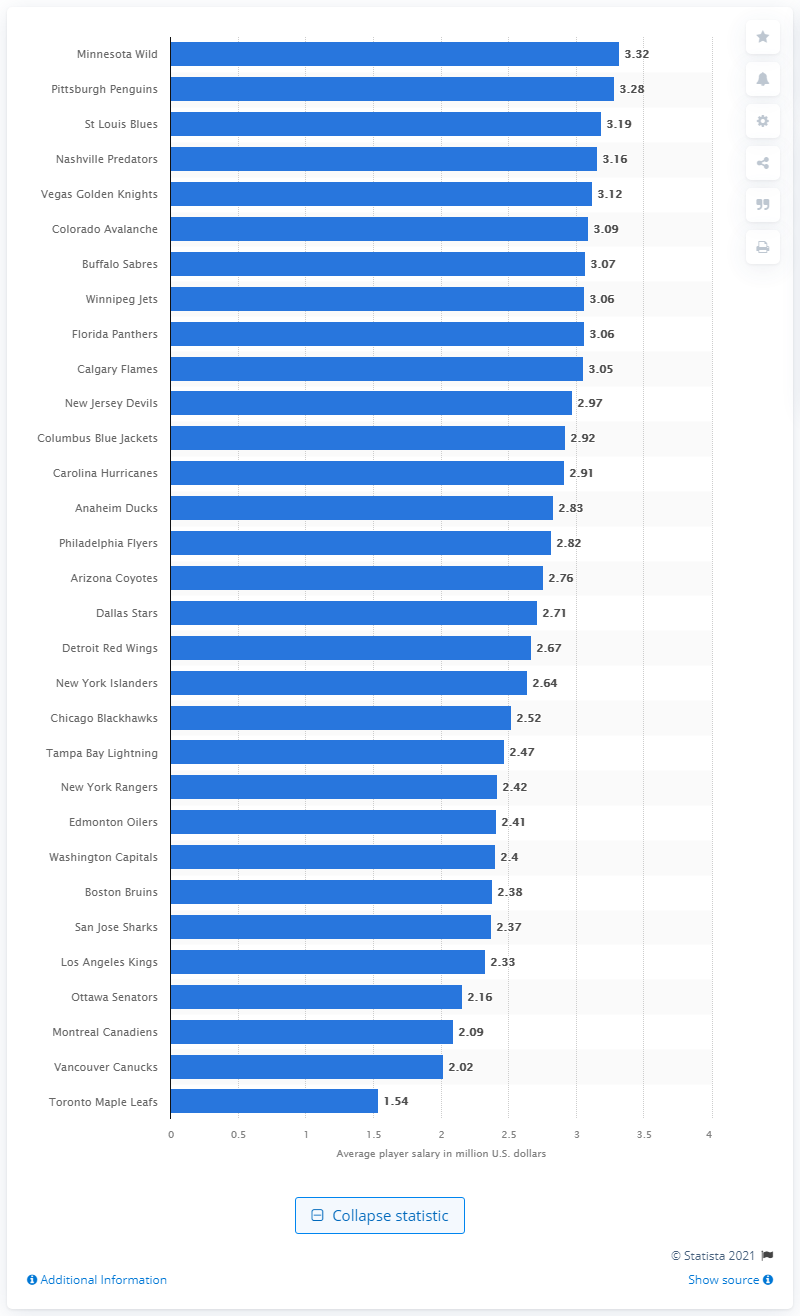Highlight a few significant elements in this photo. The Toronto Maple Leafs players earned a total of 1.54 million in the 2019/20 season. According to the 2019/20 season, the Minnesota Wild were the team with the highest average annual player salaries. 